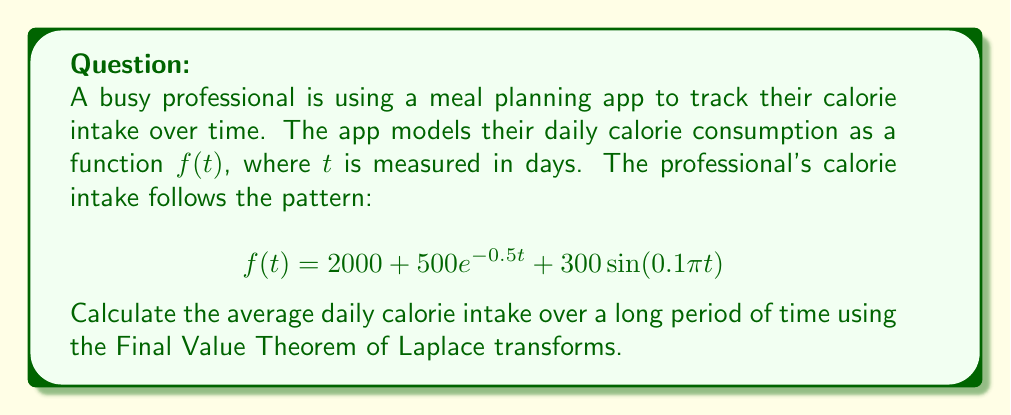Can you solve this math problem? To solve this problem, we'll follow these steps:

1) First, we need to take the Laplace transform of $f(t)$:

   $\mathcal{L}\{f(t)\} = F(s) = \mathcal{L}\{2000 + 500e^{-0.5t} + 300\sin(0.1\pi t)\}$

2) Using linearity and standard Laplace transform pairs:

   $F(s) = \frac{2000}{s} + \frac{500}{s+0.5} + \frac{300 \cdot 0.1\pi}{s^2 + (0.1\pi)^2}$

3) The Final Value Theorem states that for a function $f(t)$ with Laplace transform $F(s)$:

   $\lim_{t \to \infty} f(t) = \lim_{s \to 0} sF(s)$

4) Let's apply this theorem:

   $\lim_{s \to 0} sF(s) = \lim_{s \to 0} \left(2000 + \frac{500s}{s+0.5} + \frac{300 \cdot 0.1\pi s}{s^2 + (0.1\pi)^2}\right)$

5) Evaluating the limit:
   - The first term is constant: 2000
   - For the second term: $\lim_{s \to 0} \frac{500s}{s+0.5} = 0$
   - For the third term: $\lim_{s \to 0} \frac{300 \cdot 0.1\pi s}{s^2 + (0.1\pi)^2} = 0$

6) Therefore, the average daily calorie intake over a long period of time is 2000 calories.
Answer: The average daily calorie intake over a long period of time is 2000 calories. 